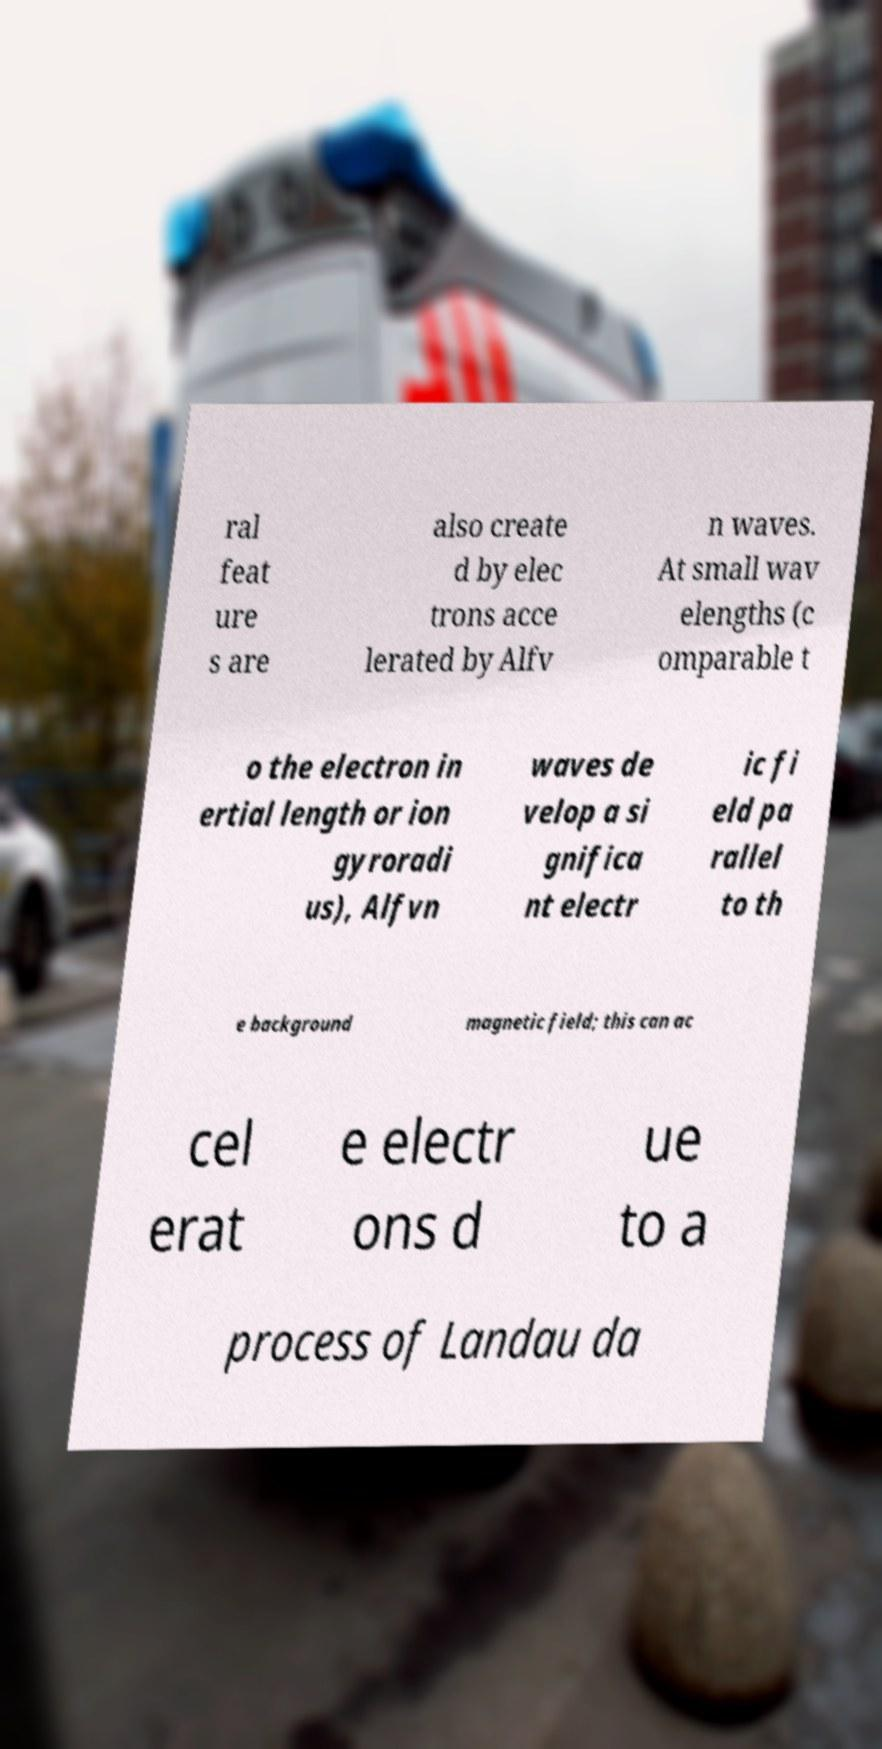Please identify and transcribe the text found in this image. ral feat ure s are also create d by elec trons acce lerated by Alfv n waves. At small wav elengths (c omparable t o the electron in ertial length or ion gyroradi us), Alfvn waves de velop a si gnifica nt electr ic fi eld pa rallel to th e background magnetic field; this can ac cel erat e electr ons d ue to a process of Landau da 